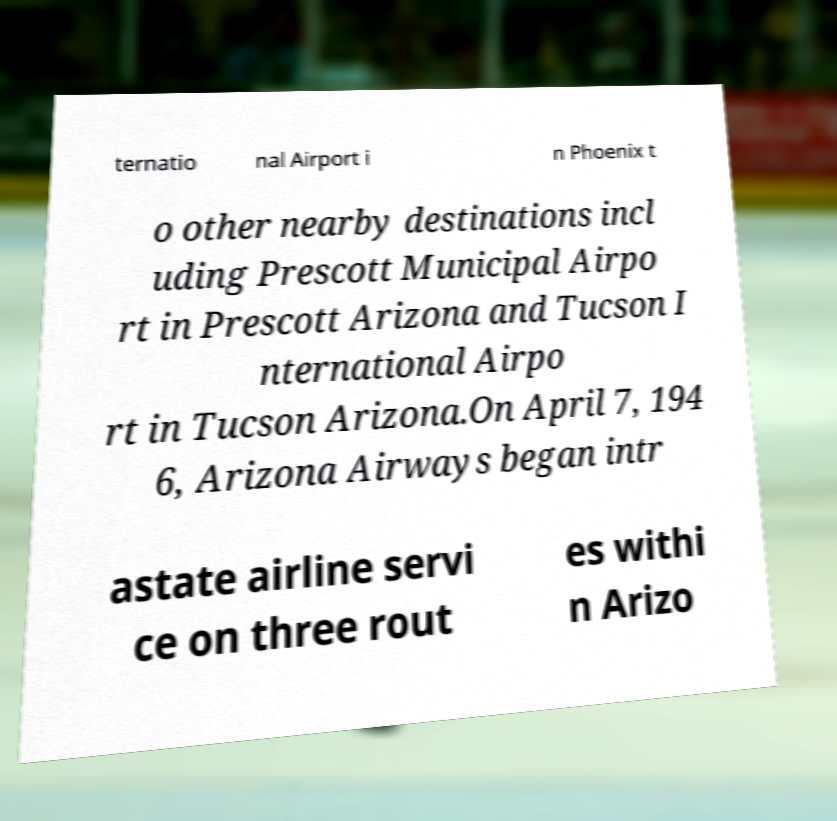Please identify and transcribe the text found in this image. ternatio nal Airport i n Phoenix t o other nearby destinations incl uding Prescott Municipal Airpo rt in Prescott Arizona and Tucson I nternational Airpo rt in Tucson Arizona.On April 7, 194 6, Arizona Airways began intr astate airline servi ce on three rout es withi n Arizo 